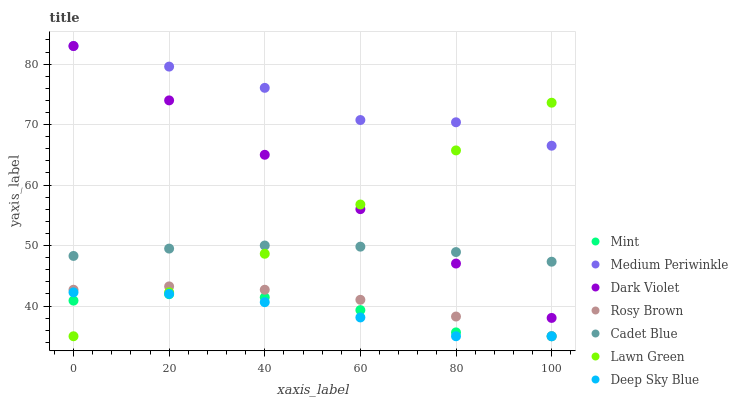Does Deep Sky Blue have the minimum area under the curve?
Answer yes or no. Yes. Does Medium Periwinkle have the maximum area under the curve?
Answer yes or no. Yes. Does Cadet Blue have the minimum area under the curve?
Answer yes or no. No. Does Cadet Blue have the maximum area under the curve?
Answer yes or no. No. Is Dark Violet the smoothest?
Answer yes or no. Yes. Is Medium Periwinkle the roughest?
Answer yes or no. Yes. Is Cadet Blue the smoothest?
Answer yes or no. No. Is Cadet Blue the roughest?
Answer yes or no. No. Does Lawn Green have the lowest value?
Answer yes or no. Yes. Does Cadet Blue have the lowest value?
Answer yes or no. No. Does Dark Violet have the highest value?
Answer yes or no. Yes. Does Cadet Blue have the highest value?
Answer yes or no. No. Is Rosy Brown less than Medium Periwinkle?
Answer yes or no. Yes. Is Medium Periwinkle greater than Deep Sky Blue?
Answer yes or no. Yes. Does Mint intersect Deep Sky Blue?
Answer yes or no. Yes. Is Mint less than Deep Sky Blue?
Answer yes or no. No. Is Mint greater than Deep Sky Blue?
Answer yes or no. No. Does Rosy Brown intersect Medium Periwinkle?
Answer yes or no. No. 